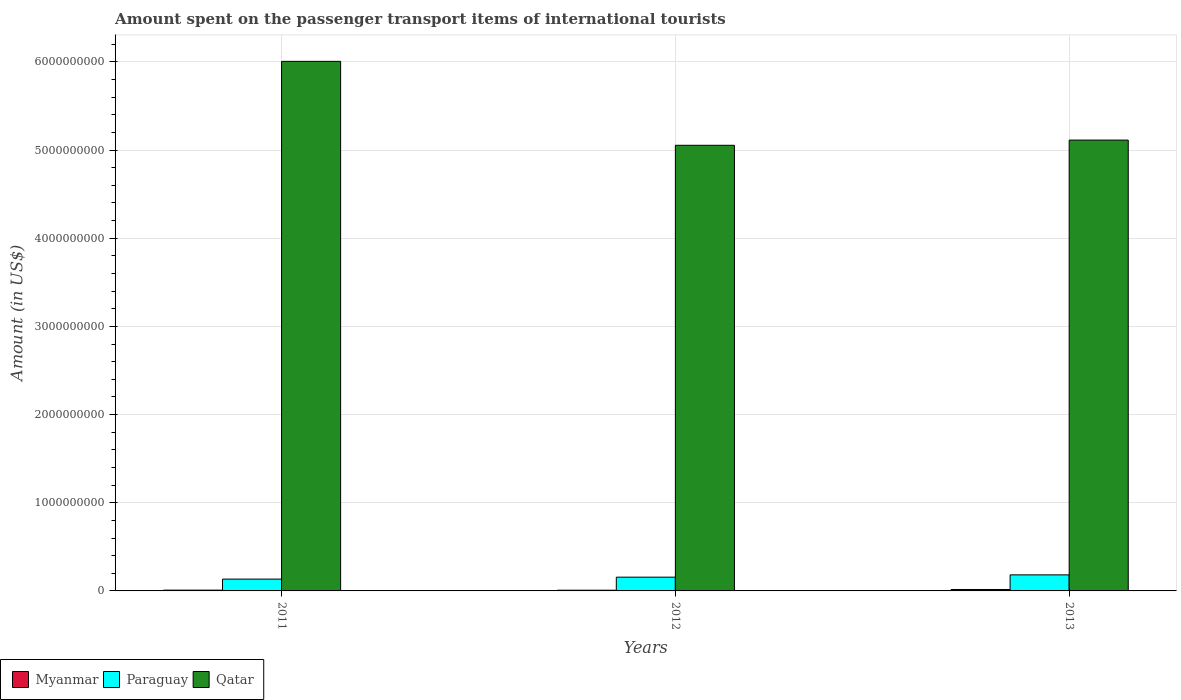Are the number of bars per tick equal to the number of legend labels?
Ensure brevity in your answer.  Yes. How many bars are there on the 3rd tick from the right?
Offer a terse response. 3. What is the label of the 3rd group of bars from the left?
Keep it short and to the point. 2013. What is the amount spent on the passenger transport items of international tourists in Qatar in 2013?
Make the answer very short. 5.11e+09. Across all years, what is the maximum amount spent on the passenger transport items of international tourists in Myanmar?
Make the answer very short. 1.60e+07. Across all years, what is the minimum amount spent on the passenger transport items of international tourists in Paraguay?
Make the answer very short. 1.34e+08. In which year was the amount spent on the passenger transport items of international tourists in Paraguay maximum?
Keep it short and to the point. 2013. What is the total amount spent on the passenger transport items of international tourists in Qatar in the graph?
Ensure brevity in your answer.  1.62e+1. What is the difference between the amount spent on the passenger transport items of international tourists in Paraguay in 2012 and that in 2013?
Keep it short and to the point. -2.60e+07. What is the difference between the amount spent on the passenger transport items of international tourists in Qatar in 2012 and the amount spent on the passenger transport items of international tourists in Myanmar in 2013?
Offer a very short reply. 5.04e+09. What is the average amount spent on the passenger transport items of international tourists in Paraguay per year?
Make the answer very short. 1.57e+08. In the year 2013, what is the difference between the amount spent on the passenger transport items of international tourists in Qatar and amount spent on the passenger transport items of international tourists in Myanmar?
Your answer should be very brief. 5.10e+09. In how many years, is the amount spent on the passenger transport items of international tourists in Qatar greater than 3600000000 US$?
Provide a succinct answer. 3. What is the ratio of the amount spent on the passenger transport items of international tourists in Paraguay in 2011 to that in 2012?
Offer a very short reply. 0.86. What is the difference between the highest and the second highest amount spent on the passenger transport items of international tourists in Paraguay?
Keep it short and to the point. 2.60e+07. What does the 1st bar from the left in 2013 represents?
Ensure brevity in your answer.  Myanmar. What does the 1st bar from the right in 2011 represents?
Offer a terse response. Qatar. How many years are there in the graph?
Provide a succinct answer. 3. What is the difference between two consecutive major ticks on the Y-axis?
Offer a very short reply. 1.00e+09. Does the graph contain any zero values?
Provide a short and direct response. No. What is the title of the graph?
Your response must be concise. Amount spent on the passenger transport items of international tourists. Does "Aruba" appear as one of the legend labels in the graph?
Offer a terse response. No. What is the label or title of the X-axis?
Ensure brevity in your answer.  Years. What is the label or title of the Y-axis?
Offer a terse response. Amount (in US$). What is the Amount (in US$) of Myanmar in 2011?
Your answer should be compact. 9.00e+06. What is the Amount (in US$) of Paraguay in 2011?
Offer a terse response. 1.34e+08. What is the Amount (in US$) of Qatar in 2011?
Keep it short and to the point. 6.01e+09. What is the Amount (in US$) of Paraguay in 2012?
Offer a terse response. 1.56e+08. What is the Amount (in US$) in Qatar in 2012?
Provide a short and direct response. 5.05e+09. What is the Amount (in US$) of Myanmar in 2013?
Your answer should be compact. 1.60e+07. What is the Amount (in US$) of Paraguay in 2013?
Offer a very short reply. 1.82e+08. What is the Amount (in US$) of Qatar in 2013?
Offer a very short reply. 5.11e+09. Across all years, what is the maximum Amount (in US$) in Myanmar?
Your response must be concise. 1.60e+07. Across all years, what is the maximum Amount (in US$) of Paraguay?
Offer a very short reply. 1.82e+08. Across all years, what is the maximum Amount (in US$) of Qatar?
Offer a terse response. 6.01e+09. Across all years, what is the minimum Amount (in US$) of Myanmar?
Your response must be concise. 8.00e+06. Across all years, what is the minimum Amount (in US$) of Paraguay?
Your answer should be compact. 1.34e+08. Across all years, what is the minimum Amount (in US$) in Qatar?
Give a very brief answer. 5.05e+09. What is the total Amount (in US$) of Myanmar in the graph?
Your answer should be very brief. 3.30e+07. What is the total Amount (in US$) of Paraguay in the graph?
Keep it short and to the point. 4.72e+08. What is the total Amount (in US$) of Qatar in the graph?
Keep it short and to the point. 1.62e+1. What is the difference between the Amount (in US$) of Myanmar in 2011 and that in 2012?
Provide a succinct answer. 1.00e+06. What is the difference between the Amount (in US$) in Paraguay in 2011 and that in 2012?
Make the answer very short. -2.20e+07. What is the difference between the Amount (in US$) in Qatar in 2011 and that in 2012?
Make the answer very short. 9.52e+08. What is the difference between the Amount (in US$) of Myanmar in 2011 and that in 2013?
Give a very brief answer. -7.00e+06. What is the difference between the Amount (in US$) of Paraguay in 2011 and that in 2013?
Give a very brief answer. -4.80e+07. What is the difference between the Amount (in US$) in Qatar in 2011 and that in 2013?
Offer a very short reply. 8.93e+08. What is the difference between the Amount (in US$) in Myanmar in 2012 and that in 2013?
Your response must be concise. -8.00e+06. What is the difference between the Amount (in US$) in Paraguay in 2012 and that in 2013?
Offer a very short reply. -2.60e+07. What is the difference between the Amount (in US$) of Qatar in 2012 and that in 2013?
Give a very brief answer. -5.90e+07. What is the difference between the Amount (in US$) in Myanmar in 2011 and the Amount (in US$) in Paraguay in 2012?
Your response must be concise. -1.47e+08. What is the difference between the Amount (in US$) of Myanmar in 2011 and the Amount (in US$) of Qatar in 2012?
Ensure brevity in your answer.  -5.04e+09. What is the difference between the Amount (in US$) of Paraguay in 2011 and the Amount (in US$) of Qatar in 2012?
Make the answer very short. -4.92e+09. What is the difference between the Amount (in US$) in Myanmar in 2011 and the Amount (in US$) in Paraguay in 2013?
Make the answer very short. -1.73e+08. What is the difference between the Amount (in US$) of Myanmar in 2011 and the Amount (in US$) of Qatar in 2013?
Give a very brief answer. -5.10e+09. What is the difference between the Amount (in US$) in Paraguay in 2011 and the Amount (in US$) in Qatar in 2013?
Keep it short and to the point. -4.98e+09. What is the difference between the Amount (in US$) in Myanmar in 2012 and the Amount (in US$) in Paraguay in 2013?
Offer a very short reply. -1.74e+08. What is the difference between the Amount (in US$) of Myanmar in 2012 and the Amount (in US$) of Qatar in 2013?
Offer a terse response. -5.10e+09. What is the difference between the Amount (in US$) in Paraguay in 2012 and the Amount (in US$) in Qatar in 2013?
Keep it short and to the point. -4.96e+09. What is the average Amount (in US$) in Myanmar per year?
Keep it short and to the point. 1.10e+07. What is the average Amount (in US$) of Paraguay per year?
Make the answer very short. 1.57e+08. What is the average Amount (in US$) in Qatar per year?
Give a very brief answer. 5.39e+09. In the year 2011, what is the difference between the Amount (in US$) in Myanmar and Amount (in US$) in Paraguay?
Offer a terse response. -1.25e+08. In the year 2011, what is the difference between the Amount (in US$) of Myanmar and Amount (in US$) of Qatar?
Your response must be concise. -6.00e+09. In the year 2011, what is the difference between the Amount (in US$) of Paraguay and Amount (in US$) of Qatar?
Make the answer very short. -5.87e+09. In the year 2012, what is the difference between the Amount (in US$) in Myanmar and Amount (in US$) in Paraguay?
Provide a succinct answer. -1.48e+08. In the year 2012, what is the difference between the Amount (in US$) of Myanmar and Amount (in US$) of Qatar?
Offer a terse response. -5.05e+09. In the year 2012, what is the difference between the Amount (in US$) in Paraguay and Amount (in US$) in Qatar?
Offer a very short reply. -4.90e+09. In the year 2013, what is the difference between the Amount (in US$) of Myanmar and Amount (in US$) of Paraguay?
Give a very brief answer. -1.66e+08. In the year 2013, what is the difference between the Amount (in US$) in Myanmar and Amount (in US$) in Qatar?
Offer a terse response. -5.10e+09. In the year 2013, what is the difference between the Amount (in US$) in Paraguay and Amount (in US$) in Qatar?
Offer a terse response. -4.93e+09. What is the ratio of the Amount (in US$) in Myanmar in 2011 to that in 2012?
Make the answer very short. 1.12. What is the ratio of the Amount (in US$) of Paraguay in 2011 to that in 2012?
Offer a very short reply. 0.86. What is the ratio of the Amount (in US$) of Qatar in 2011 to that in 2012?
Your response must be concise. 1.19. What is the ratio of the Amount (in US$) of Myanmar in 2011 to that in 2013?
Offer a very short reply. 0.56. What is the ratio of the Amount (in US$) in Paraguay in 2011 to that in 2013?
Your response must be concise. 0.74. What is the ratio of the Amount (in US$) in Qatar in 2011 to that in 2013?
Provide a succinct answer. 1.17. What is the ratio of the Amount (in US$) of Qatar in 2012 to that in 2013?
Your answer should be very brief. 0.99. What is the difference between the highest and the second highest Amount (in US$) of Myanmar?
Your response must be concise. 7.00e+06. What is the difference between the highest and the second highest Amount (in US$) in Paraguay?
Offer a very short reply. 2.60e+07. What is the difference between the highest and the second highest Amount (in US$) in Qatar?
Provide a succinct answer. 8.93e+08. What is the difference between the highest and the lowest Amount (in US$) in Paraguay?
Give a very brief answer. 4.80e+07. What is the difference between the highest and the lowest Amount (in US$) in Qatar?
Your answer should be very brief. 9.52e+08. 